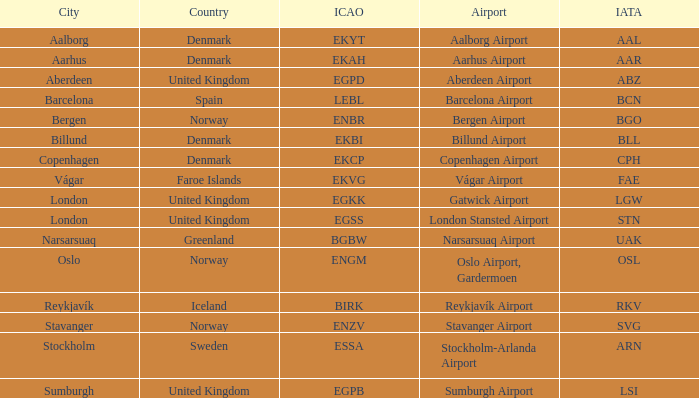What is the ICAO for Denmark, and the IATA is bll? EKBI. 